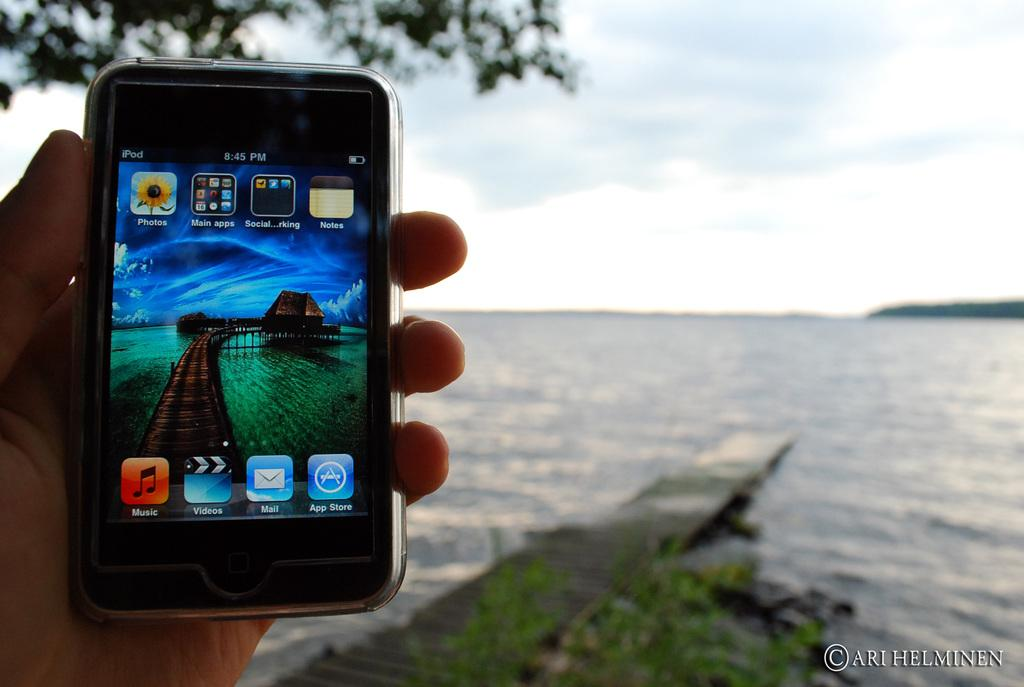<image>
Summarize the visual content of the image. Someone holds up a phone showing that the time is 8:45 PM. 